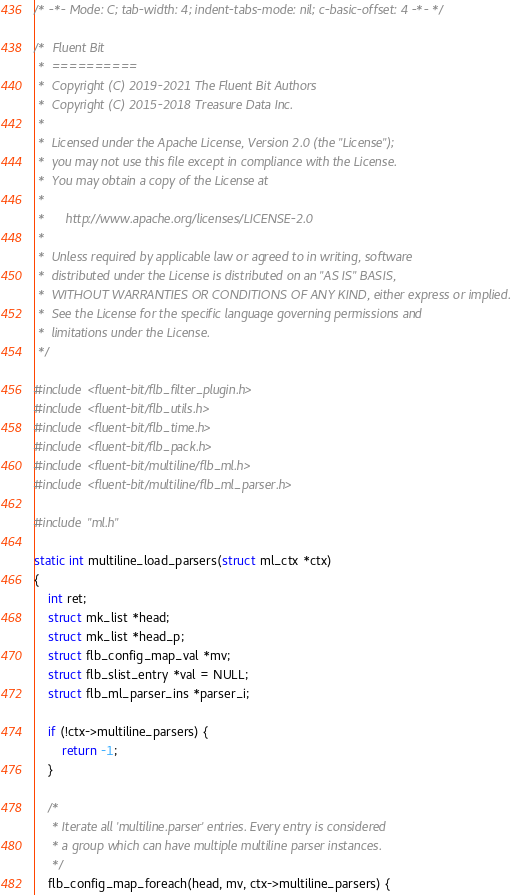Convert code to text. <code><loc_0><loc_0><loc_500><loc_500><_C_>/* -*- Mode: C; tab-width: 4; indent-tabs-mode: nil; c-basic-offset: 4 -*- */

/*  Fluent Bit
 *  ==========
 *  Copyright (C) 2019-2021 The Fluent Bit Authors
 *  Copyright (C) 2015-2018 Treasure Data Inc.
 *
 *  Licensed under the Apache License, Version 2.0 (the "License");
 *  you may not use this file except in compliance with the License.
 *  You may obtain a copy of the License at
 *
 *      http://www.apache.org/licenses/LICENSE-2.0
 *
 *  Unless required by applicable law or agreed to in writing, software
 *  distributed under the License is distributed on an "AS IS" BASIS,
 *  WITHOUT WARRANTIES OR CONDITIONS OF ANY KIND, either express or implied.
 *  See the License for the specific language governing permissions and
 *  limitations under the License.
 */

#include <fluent-bit/flb_filter_plugin.h>
#include <fluent-bit/flb_utils.h>
#include <fluent-bit/flb_time.h>
#include <fluent-bit/flb_pack.h>
#include <fluent-bit/multiline/flb_ml.h>
#include <fluent-bit/multiline/flb_ml_parser.h>

#include "ml.h"

static int multiline_load_parsers(struct ml_ctx *ctx)
{
    int ret;
    struct mk_list *head;
    struct mk_list *head_p;
    struct flb_config_map_val *mv;
    struct flb_slist_entry *val = NULL;
    struct flb_ml_parser_ins *parser_i;

    if (!ctx->multiline_parsers) {
        return -1;
    }

    /*
     * Iterate all 'multiline.parser' entries. Every entry is considered
     * a group which can have multiple multiline parser instances.
     */
    flb_config_map_foreach(head, mv, ctx->multiline_parsers) {</code> 